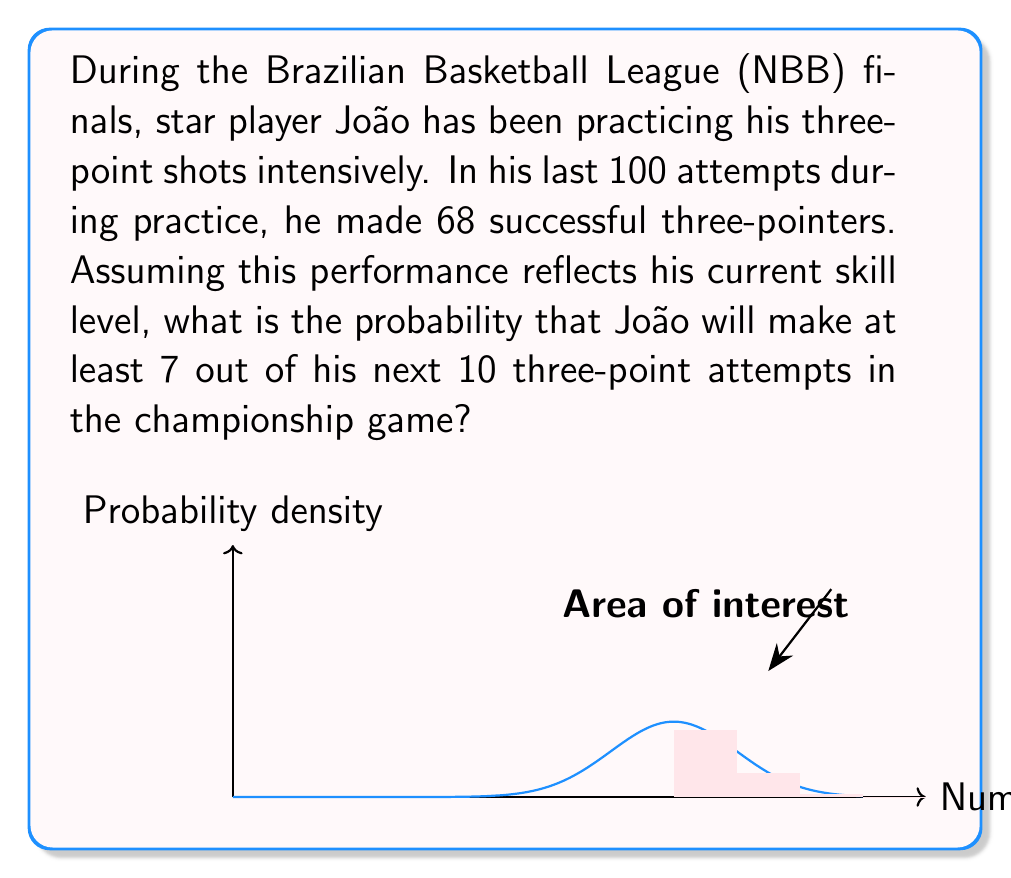Can you answer this question? To solve this problem, we'll use the binomial distribution and cumulative probability. Let's break it down step-by-step:

1) First, let's define our variables:
   $p$ = probability of success for a single shot
   $n$ = number of attempts
   $k$ = minimum number of successes we're interested in

2) From the practice data:
   $p = 68/100 = 0.68$
   $n = 10$
   $k = 7$ (we want at least 7 successes)

3) The probability of exactly $x$ successes in $n$ trials is given by the binomial probability formula:

   $P(X = x) = \binom{n}{x} p^x (1-p)^{n-x}$

4) We want the probability of 7, 8, 9, or 10 successes. So we need to sum these individual probabilities:

   $P(X \geq 7) = P(X = 7) + P(X = 8) + P(X = 9) + P(X = 10)$

5) Let's calculate each term:

   $P(X = 7) = \binom{10}{7} 0.68^7 (1-0.68)^{3} = 120 \cdot 0.68^7 \cdot 0.32^3 \approx 0.2214$
   
   $P(X = 8) = \binom{10}{8} 0.68^8 (1-0.68)^{2} = 45 \cdot 0.68^8 \cdot 0.32^2 \approx 0.2360$
   
   $P(X = 9) = \binom{10}{9} 0.68^9 (1-0.68)^{1} = 10 \cdot 0.68^9 \cdot 0.32^1 \approx 0.1329$
   
   $P(X = 10) = \binom{10}{10} 0.68^{10} (1-0.68)^{0} = 1 \cdot 0.68^{10} \approx 0.0282$

6) Sum these probabilities:

   $P(X \geq 7) = 0.2214 + 0.2360 + 0.1329 + 0.0282 = 0.6185$

Therefore, the probability that João will make at least 7 out of his next 10 three-point attempts is approximately 0.6185 or 61.85%.
Answer: $0.6185$ or $61.85\%$ 